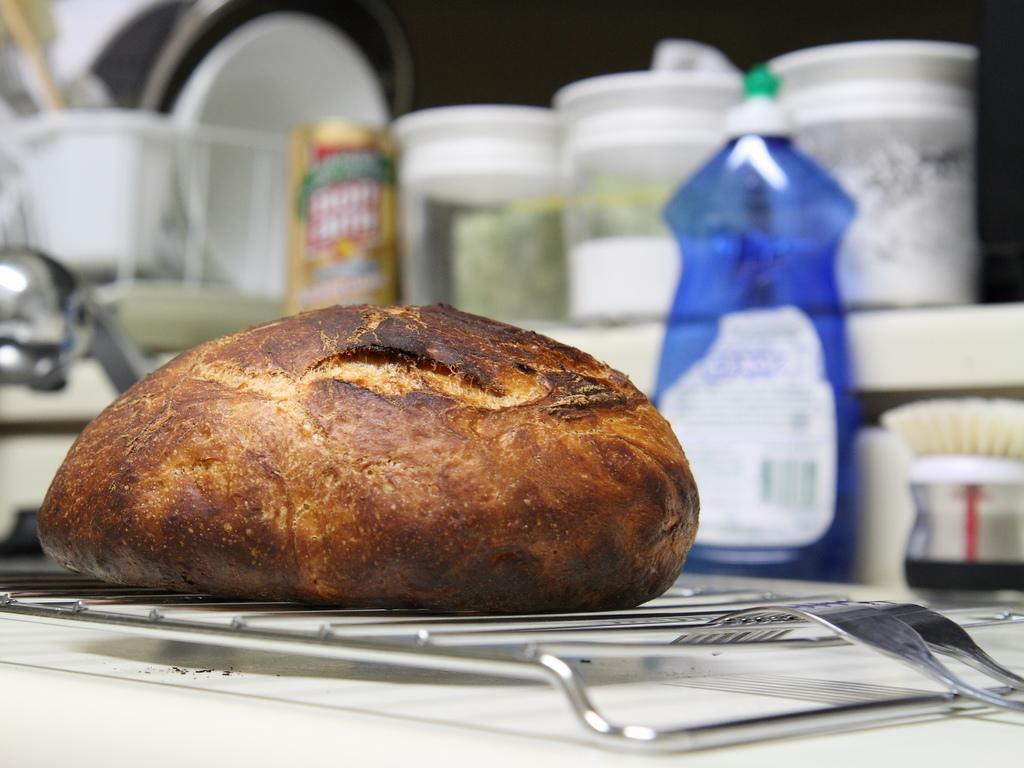Describe this image in one or two sentences. In this i can see a a bread kept on the table and there are forks kept on the table and there are the bowls visible on the back ground. 